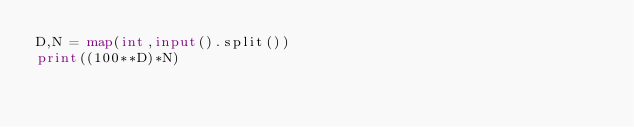Convert code to text. <code><loc_0><loc_0><loc_500><loc_500><_Python_>D,N = map(int,input().split())
print((100**D)*N)</code> 